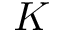<formula> <loc_0><loc_0><loc_500><loc_500>K</formula> 